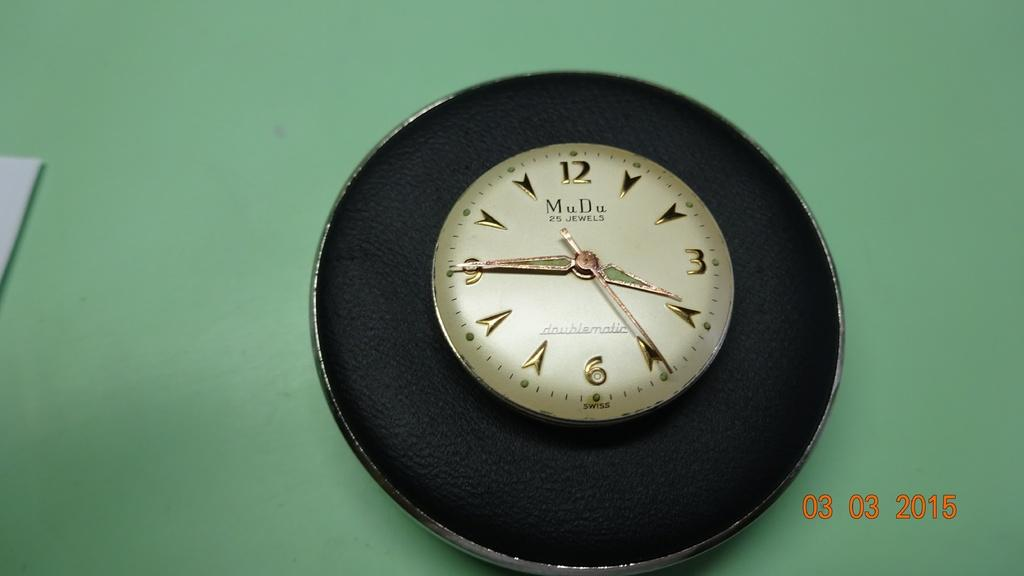<image>
Provide a brief description of the given image. A picture of a clock that was taken on March 3, 2015. 